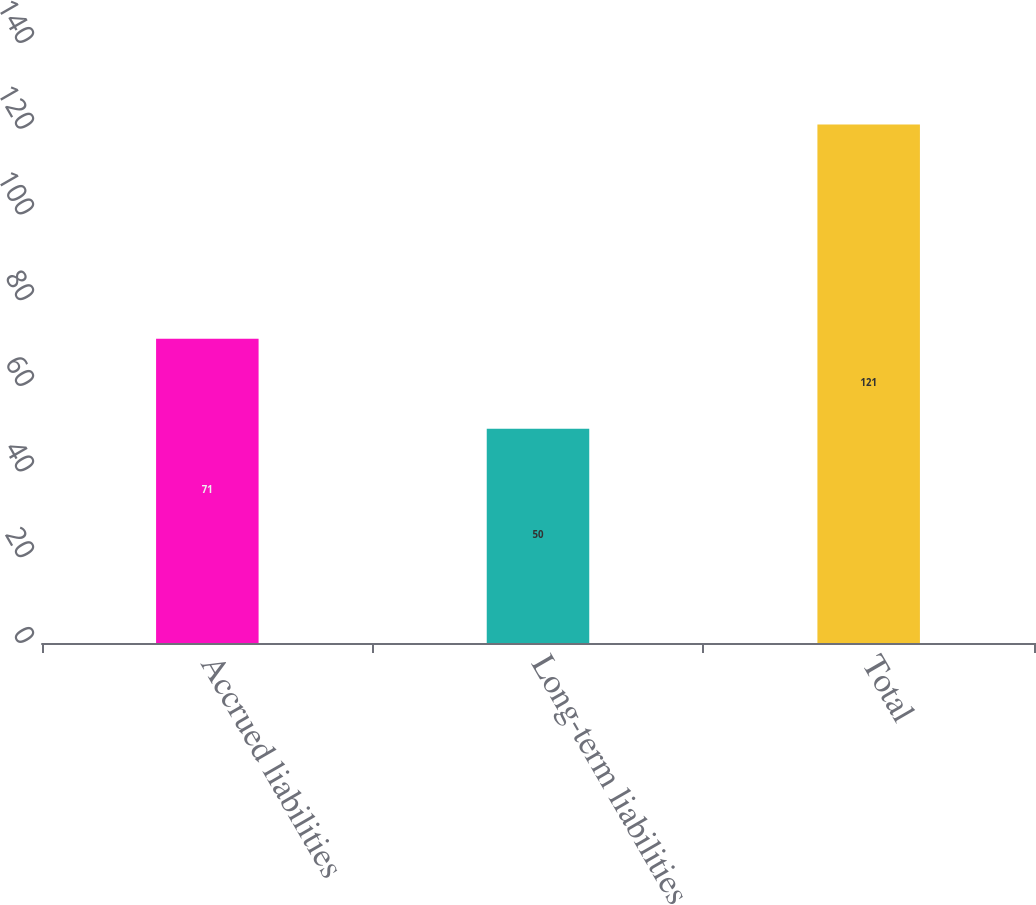Convert chart. <chart><loc_0><loc_0><loc_500><loc_500><bar_chart><fcel>Accrued liabilities<fcel>Long-term liabilities<fcel>Total<nl><fcel>71<fcel>50<fcel>121<nl></chart> 